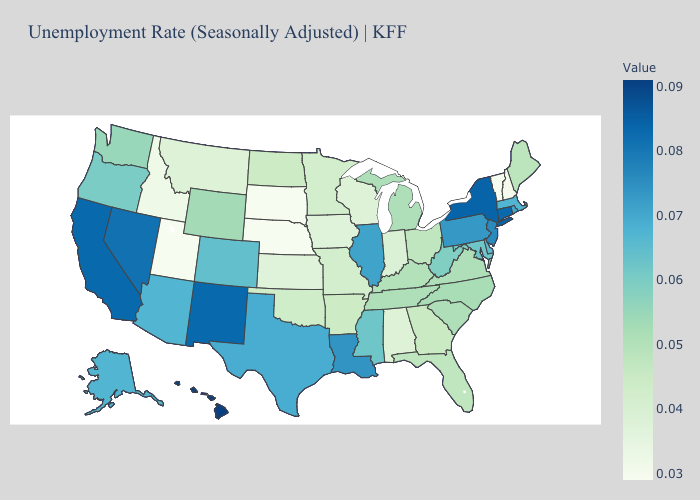Does Iowa have the highest value in the USA?
Be succinct. No. Does Alabama have the lowest value in the South?
Write a very short answer. Yes. Which states have the lowest value in the Northeast?
Give a very brief answer. Vermont. Among the states that border Rhode Island , which have the lowest value?
Be succinct. Massachusetts. Does the map have missing data?
Short answer required. No. Among the states that border Colorado , does New Mexico have the lowest value?
Keep it brief. No. Which states have the lowest value in the USA?
Be succinct. Nebraska, South Dakota, Utah, Vermont. Does Illinois have the highest value in the MidWest?
Short answer required. Yes. Does New Hampshire have the highest value in the Northeast?
Be succinct. No. Does Illinois have the highest value in the MidWest?
Give a very brief answer. Yes. Which states have the lowest value in the USA?
Give a very brief answer. Nebraska, South Dakota, Utah, Vermont. 